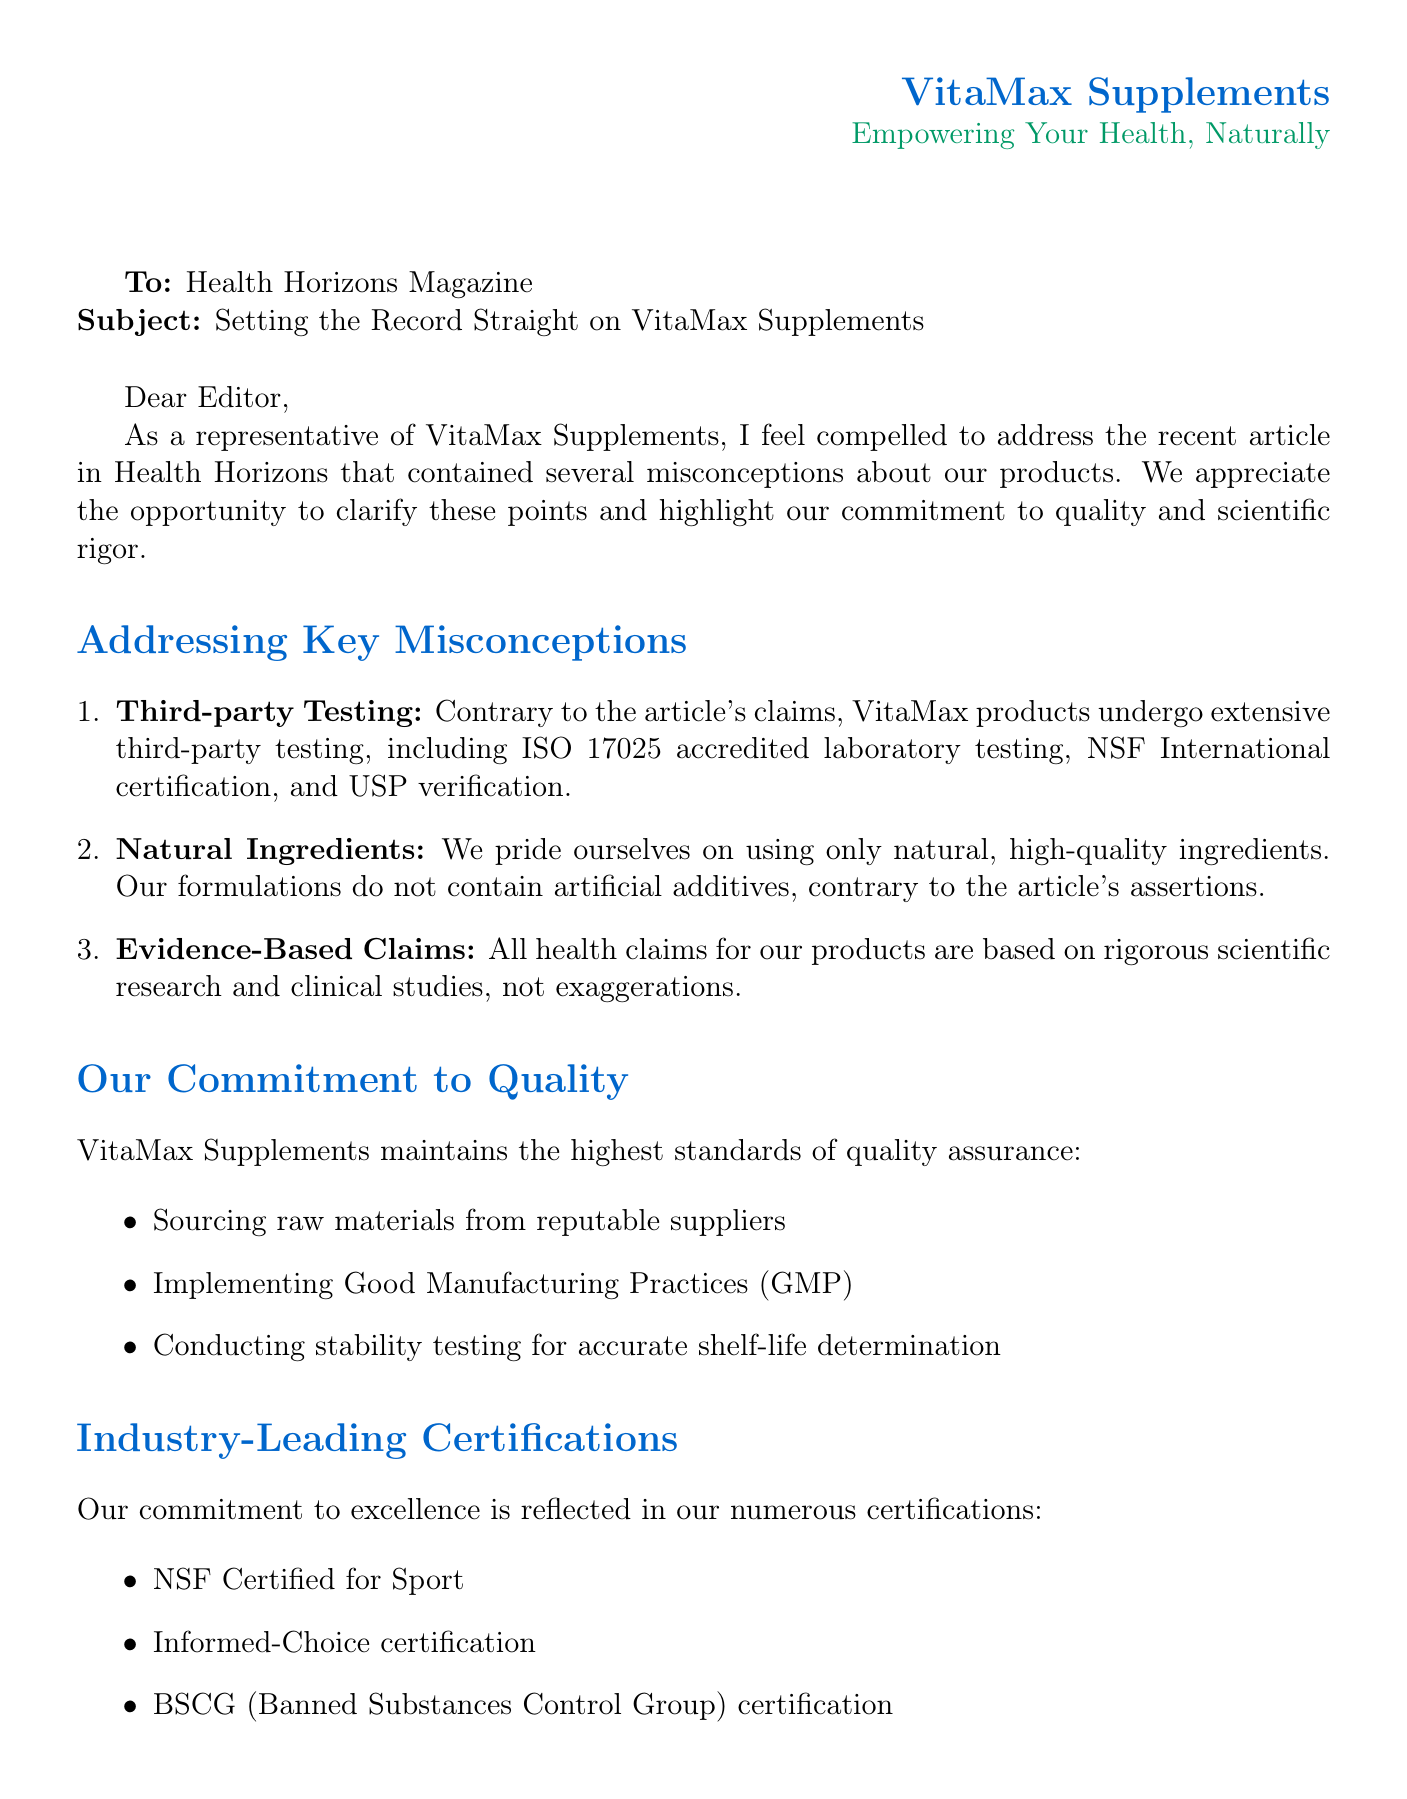What are the product lines offered by VitaMax? The document lists the specific product lines that VitaMax offers, which are "VitaMax Elite Performance", "VitaMax Daily Essentials", and "VitaMax Targeted Nutrition".
Answer: VitaMax Elite Performance, VitaMax Daily Essentials, VitaMax Targeted Nutrition What certifications does VitaMax hold? The document provides a list of certifications held by VitaMax, including NSF Certified for Sport, Informed-Choice certification, and BSCG certification.
Answer: NSF Certified for Sport, Informed-Choice certification, BSCG certification Who is Sarah Johnson? The document includes a customer testimonial from Sarah Johnson, identifying her profession and experience.
Answer: Professional athlete What testing processes are mentioned in the letter? The letter details the rigorous testing processes used by VitaMax, specifically ISO 17025 accredited laboratory testing, NSF International certification, and USP verification.
Answer: ISO 17025 accredited laboratory testing, NSF International certification, USP verification What type of environmental initiatives does VitaMax pursue? The letter highlights specific environmental initiatives undertaken by VitaMax, including recyclable packaging and a carbon-neutral manufacturing process.
Answer: 100% recyclable packaging, carbon-neutral manufacturing process How does VitaMax ensure the quality of their products? The document explains several measures implemented by VitaMax to maintain quality assurance, such as sourcing from reputable suppliers and conducting stability testing.
Answer: Sourcing raw materials from reputable suppliers, implementing Good Manufacturing Practices, conducting stability testing What recognition has VitaMax received in the industry? The letter mentions specific awards given to VitaMax, emphasizing its recognition in the nutritional supplement industry for supply chain transparency and innovation.
Answer: 2022 Nutrition Business Journal Award for Supply Chain Transparency, 2023 Natural Products Expo Innovation Award What is the main purpose of this letter? The document aims to clarify misconceptions about VitaMax products and emphasize the company's commitment to quality and scientific integrity.
Answer: To address misconceptions and emphasize quality and scientific integrity 